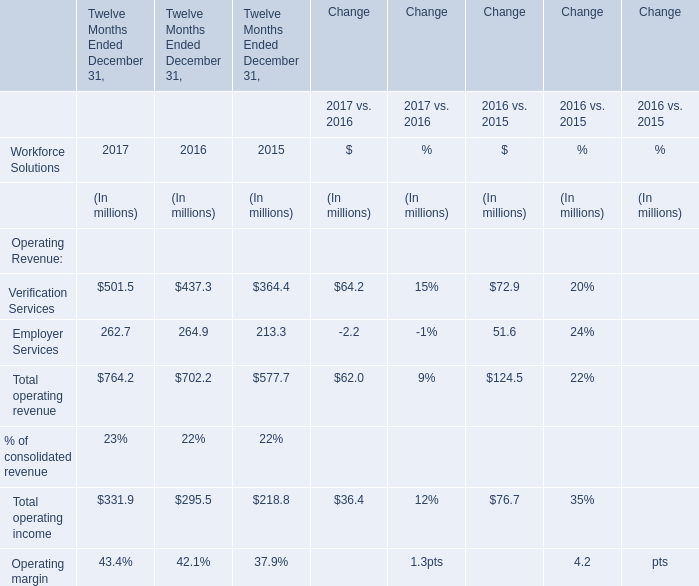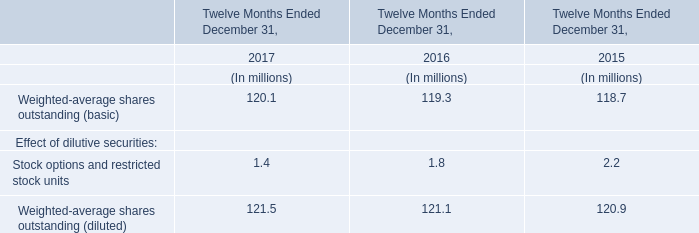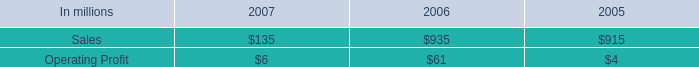Which year/section is Verification Services the most? (in million) 
Answer: 2017. 